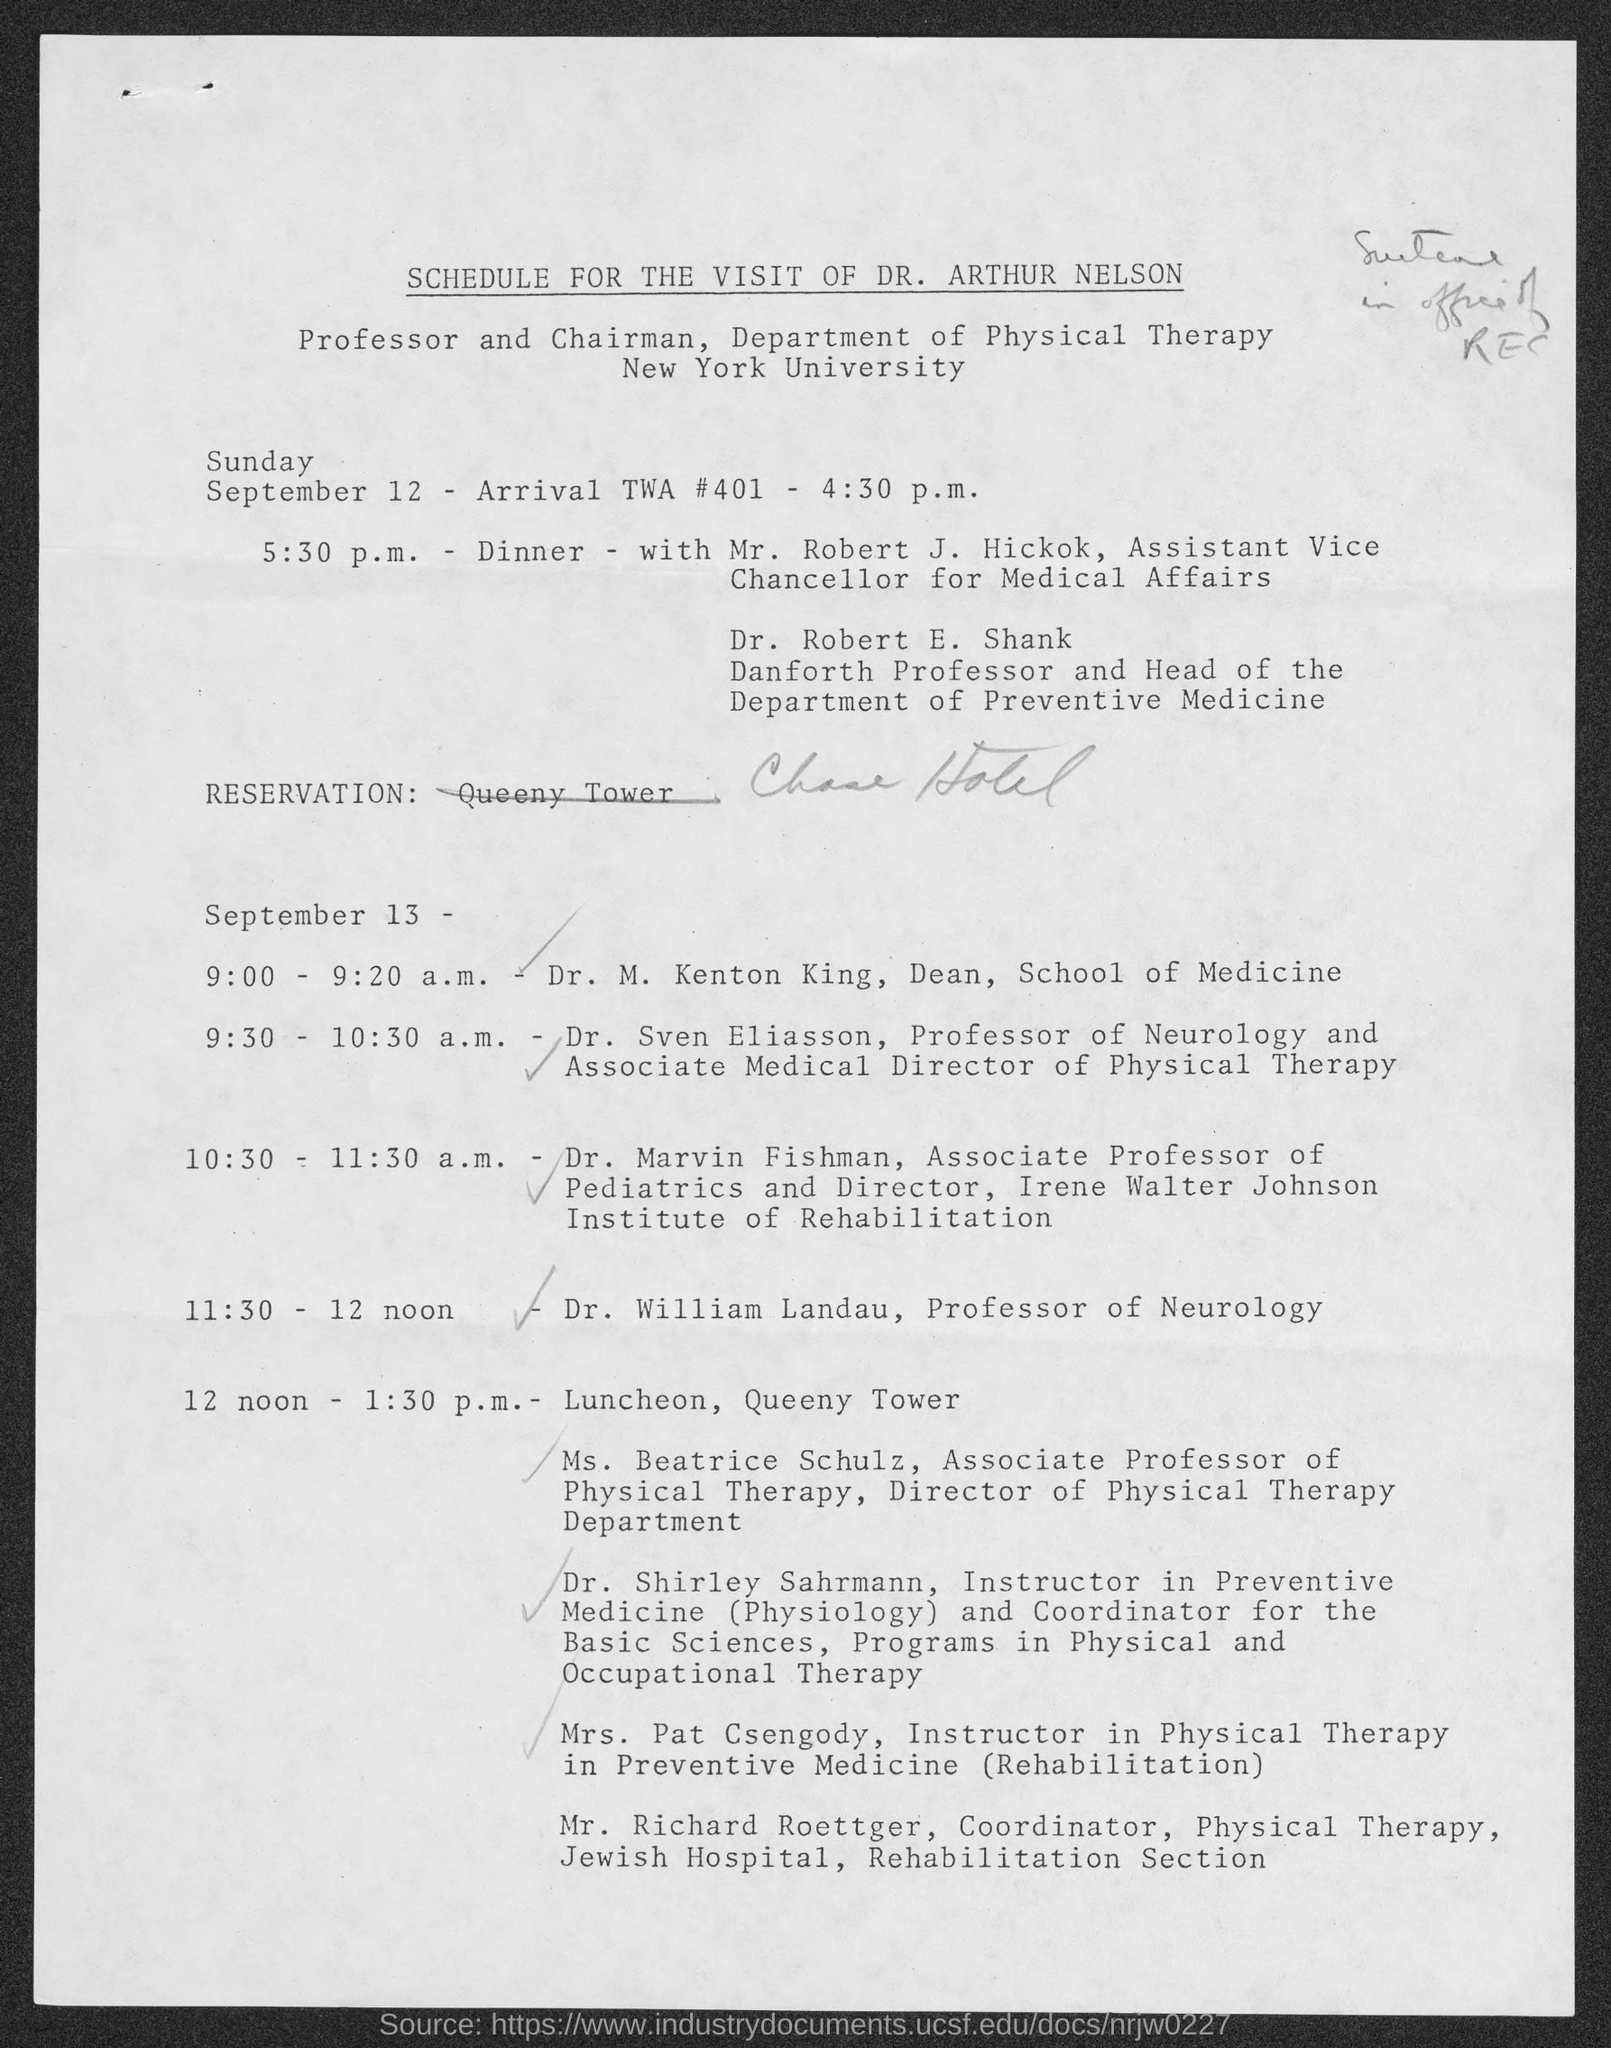Highlight a few significant elements in this photo. The document title is a schedule for the visit of Dr. Arthur Nelson. The location of the luncheon is Queeny Tower. 